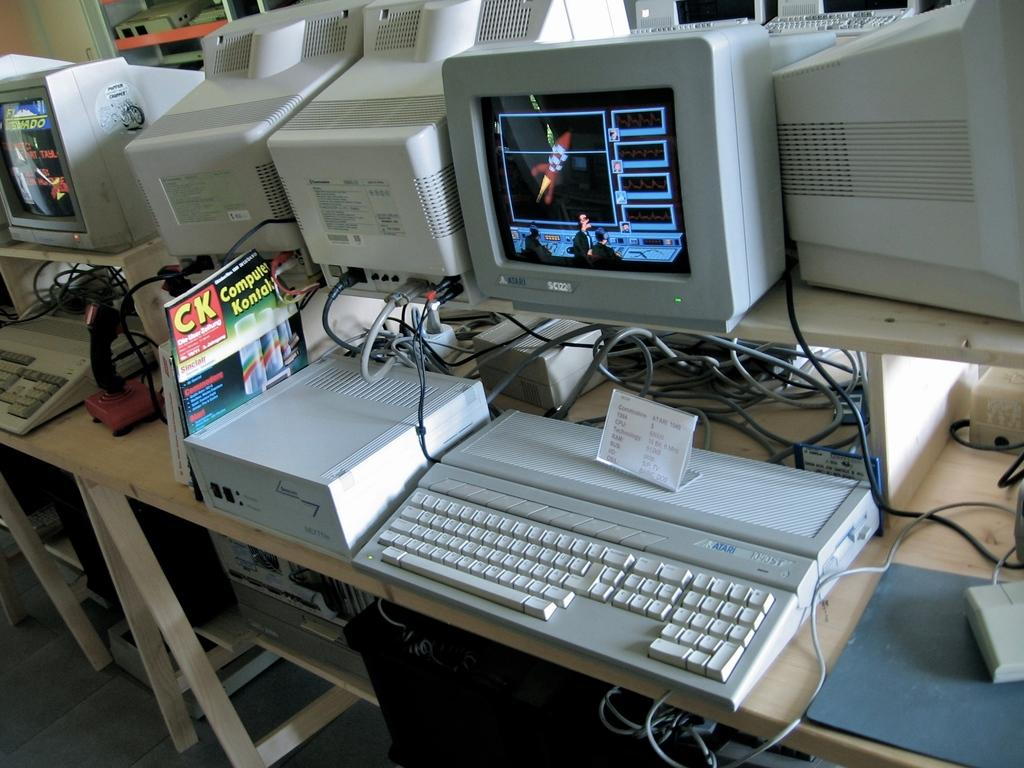<image>
Summarize the visual content of the image. A CK magazine is wedged between some equipment on a table full of computers. 